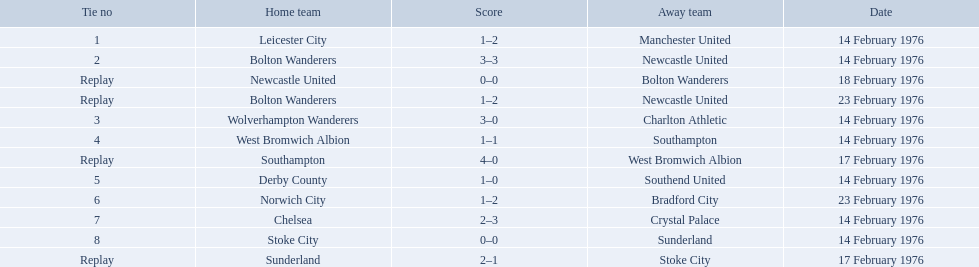Who were all of the teams? Leicester City, Manchester United, Bolton Wanderers, Newcastle United, Newcastle United, Bolton Wanderers, Bolton Wanderers, Newcastle United, Wolverhampton Wanderers, Charlton Athletic, West Bromwich Albion, Southampton, Southampton, West Bromwich Albion, Derby County, Southend United, Norwich City, Bradford City, Chelsea, Crystal Palace, Stoke City, Sunderland, Sunderland, Stoke City. And what were their scores? 1–2, 3–3, 0–0, 1–2, 3–0, 1–1, 4–0, 1–0, 1–2, 2–3, 0–0, 2–1. Between manchester and wolverhampton, who scored more? Wolverhampton Wanderers. What is the game at the top of the table? 1. Who is the home team for this game? Leicester City. Which were the host teams in the 1975-76 fa cup? Leicester City, Bolton Wanderers, Newcastle United, Bolton Wanderers, Wolverhampton Wanderers, West Bromwich Albion, Southampton, Derby County, Norwich City, Chelsea, Stoke City, Sunderland. Which among them had the tie number 1? Leicester City. Which teams participated in the game? Leicester City, Manchester United, Bolton Wanderers, Newcastle United, Newcastle United, Bolton Wanderers, Bolton Wanderers, Newcastle United, Wolverhampton Wanderers, Charlton Athletic, West Bromwich Albion, Southampton, Southampton, West Bromwich Albion, Derby County, Southend United, Norwich City, Bradford City, Chelsea, Crystal Palace, Stoke City, Sunderland, Sunderland, Stoke City. Among them, which team emerged victorious? Manchester United, Newcastle United, Wolverhampton Wanderers, Southampton, Derby County, Bradford City, Crystal Palace, Sunderland. What was the winning score for manchester united? 1–2. What was the winning score for wolverhampton wanderers? 3–0. Which of these two teams had a higher winning score? Wolverhampton Wanderers. Who were the participating teams? Leicester City, Manchester United, Bolton Wanderers, Newcastle United, Newcastle United, Bolton Wanderers, Bolton Wanderers, Newcastle United, Wolverhampton Wanderers, Charlton Athletic, West Bromwich Albion, Southampton, Southampton, West Bromwich Albion, Derby County, Southend United, Norwich City, Bradford City, Chelsea, Crystal Palace, Stoke City, Sunderland, Sunderland, Stoke City. Which team secured a win? Manchester United, Newcastle United, Wolverhampton Wanderers, Southampton, Derby County, Bradford City, Crystal Palace, Sunderland. What was the winning score of manchester united? 1–2. What was wolverhampton wanderers' winning score? 3–0. Out of these two teams, which one had a better winning score? Wolverhampton Wanderers. 